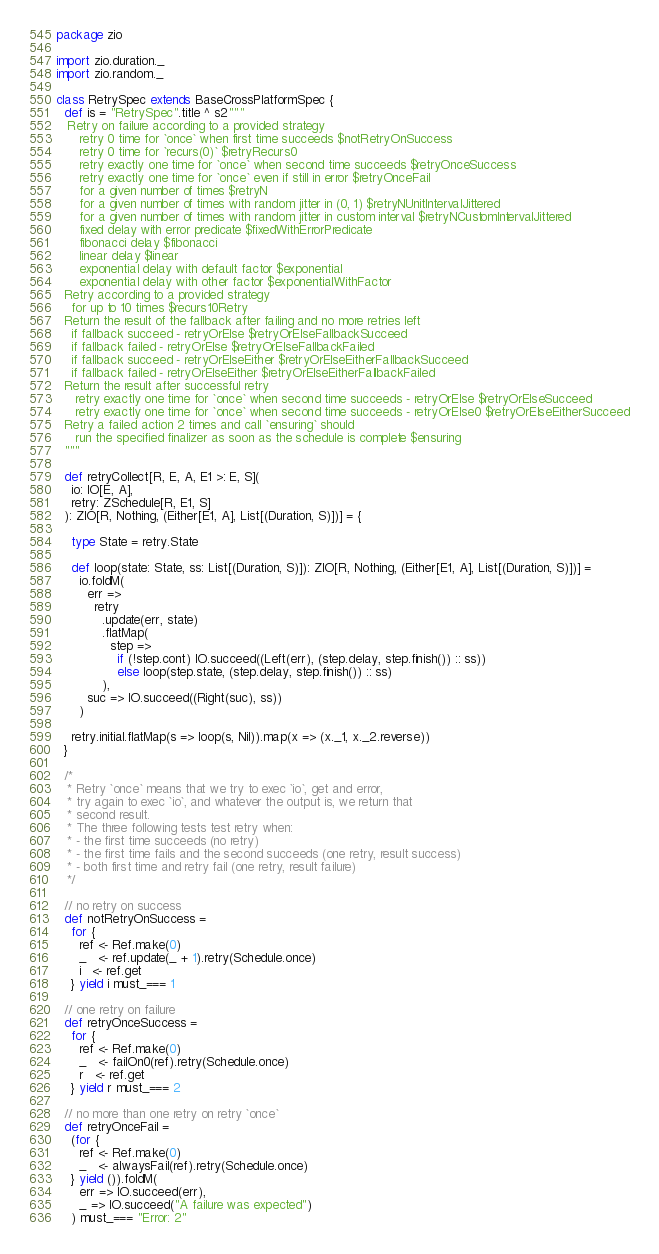Convert code to text. <code><loc_0><loc_0><loc_500><loc_500><_Scala_>package zio

import zio.duration._
import zio.random._

class RetrySpec extends BaseCrossPlatformSpec {
  def is = "RetrySpec".title ^ s2"""
   Retry on failure according to a provided strategy
      retry 0 time for `once` when first time succeeds $notRetryOnSuccess
      retry 0 time for `recurs(0)` $retryRecurs0
      retry exactly one time for `once` when second time succeeds $retryOnceSuccess
      retry exactly one time for `once` even if still in error $retryOnceFail
      for a given number of times $retryN
      for a given number of times with random jitter in (0, 1) $retryNUnitIntervalJittered
      for a given number of times with random jitter in custom interval $retryNCustomIntervalJittered
      fixed delay with error predicate $fixedWithErrorPredicate
      fibonacci delay $fibonacci
      linear delay $linear
      exponential delay with default factor $exponential
      exponential delay with other factor $exponentialWithFactor
  Retry according to a provided strategy
    for up to 10 times $recurs10Retry
  Return the result of the fallback after failing and no more retries left
    if fallback succeed - retryOrElse $retryOrElseFallbackSucceed
    if fallback failed - retryOrElse $retryOrElseFallbackFailed
    if fallback succeed - retryOrElseEither $retryOrElseEitherFallbackSucceed
    if fallback failed - retryOrElseEither $retryOrElseEitherFallbackFailed
  Return the result after successful retry
     retry exactly one time for `once` when second time succeeds - retryOrElse $retryOrElseSucceed
     retry exactly one time for `once` when second time succeeds - retryOrElse0 $retryOrElseEitherSucceed
  Retry a failed action 2 times and call `ensuring` should
     run the specified finalizer as soon as the schedule is complete $ensuring
  """

  def retryCollect[R, E, A, E1 >: E, S](
    io: IO[E, A],
    retry: ZSchedule[R, E1, S]
  ): ZIO[R, Nothing, (Either[E1, A], List[(Duration, S)])] = {

    type State = retry.State

    def loop(state: State, ss: List[(Duration, S)]): ZIO[R, Nothing, (Either[E1, A], List[(Duration, S)])] =
      io.foldM(
        err =>
          retry
            .update(err, state)
            .flatMap(
              step =>
                if (!step.cont) IO.succeed((Left(err), (step.delay, step.finish()) :: ss))
                else loop(step.state, (step.delay, step.finish()) :: ss)
            ),
        suc => IO.succeed((Right(suc), ss))
      )

    retry.initial.flatMap(s => loop(s, Nil)).map(x => (x._1, x._2.reverse))
  }

  /*
   * Retry `once` means that we try to exec `io`, get and error,
   * try again to exec `io`, and whatever the output is, we return that
   * second result.
   * The three following tests test retry when:
   * - the first time succeeds (no retry)
   * - the first time fails and the second succeeds (one retry, result success)
   * - both first time and retry fail (one retry, result failure)
   */

  // no retry on success
  def notRetryOnSuccess =
    for {
      ref <- Ref.make(0)
      _   <- ref.update(_ + 1).retry(Schedule.once)
      i   <- ref.get
    } yield i must_=== 1

  // one retry on failure
  def retryOnceSuccess =
    for {
      ref <- Ref.make(0)
      _   <- failOn0(ref).retry(Schedule.once)
      r   <- ref.get
    } yield r must_=== 2

  // no more than one retry on retry `once`
  def retryOnceFail =
    (for {
      ref <- Ref.make(0)
      _   <- alwaysFail(ref).retry(Schedule.once)
    } yield ()).foldM(
      err => IO.succeed(err),
      _ => IO.succeed("A failure was expected")
    ) must_=== "Error: 2"
</code> 